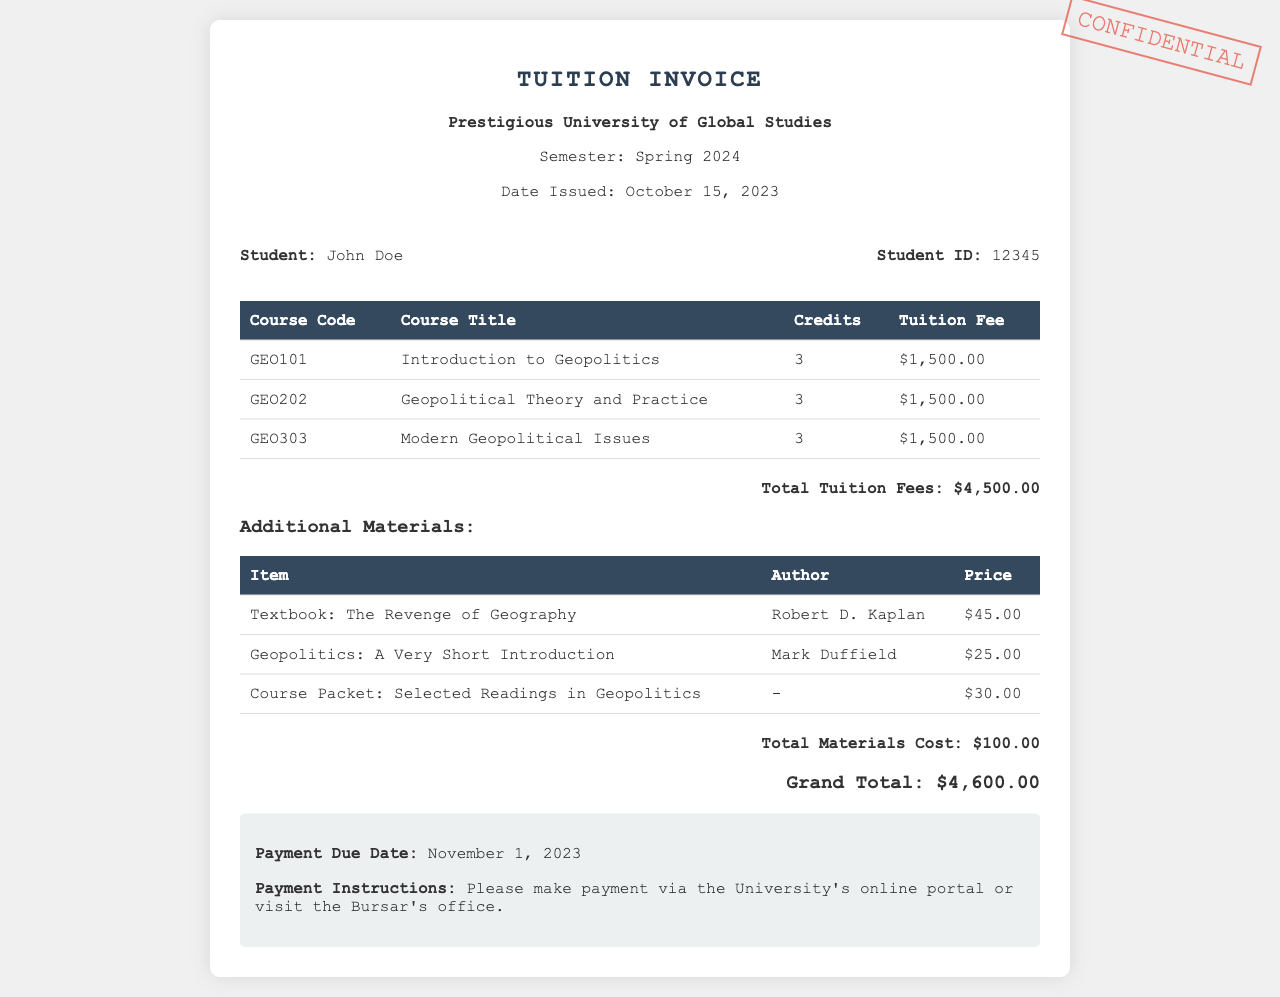What is the name of the student? The name of the student is stated in the student info section of the document as John Doe.
Answer: John Doe What is the semester for the tuition invoice? The document clearly states the semester as Spring 2024.
Answer: Spring 2024 How much is the tuition fee for GEO202? The tuition fee for GEO202 can be found in the course fee table as $1,500.00.
Answer: $1,500.00 What is the total cost for additional materials? The additional materials section lists the total materials cost as $100.00.
Answer: $100.00 What is the grand total for tuition and materials? The grand total is calculated by adding the total tuition fees and total materials cost, which is $4,500.00 + $100.00.
Answer: $4,600.00 When is the payment due date? The payment due date is specified in the payment info section as November 1, 2023.
Answer: November 1, 2023 How many credits is GEO101 worth? The credits for GEO101 are mentioned in the course fee table as 3.
Answer: 3 Who is the author of "The Revenge of Geography"? The document provides the author’s name in the materials section as Robert D. Kaplan.
Answer: Robert D. Kaplan What is the total number of courses listed in the invoice? The invoice lists three courses, which can be counted in the course fee table.
Answer: 3 What payment methods are mentioned? The payment instructions state that payment can be made via the University's online portal or at the Bursar's office.
Answer: Online portal or Bursar's office 